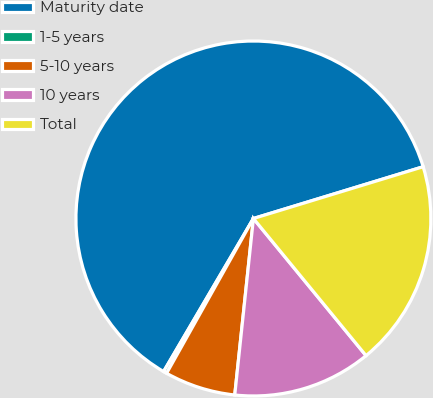<chart> <loc_0><loc_0><loc_500><loc_500><pie_chart><fcel>Maturity date<fcel>1-5 years<fcel>5-10 years<fcel>10 years<fcel>Total<nl><fcel>61.85%<fcel>0.31%<fcel>6.46%<fcel>12.62%<fcel>18.77%<nl></chart> 